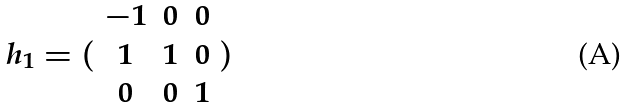<formula> <loc_0><loc_0><loc_500><loc_500>h _ { 1 } = ( \begin{array} { c c c } - 1 & 0 & 0 \\ 1 & 1 & 0 \\ 0 & 0 & 1 \end{array} )</formula> 